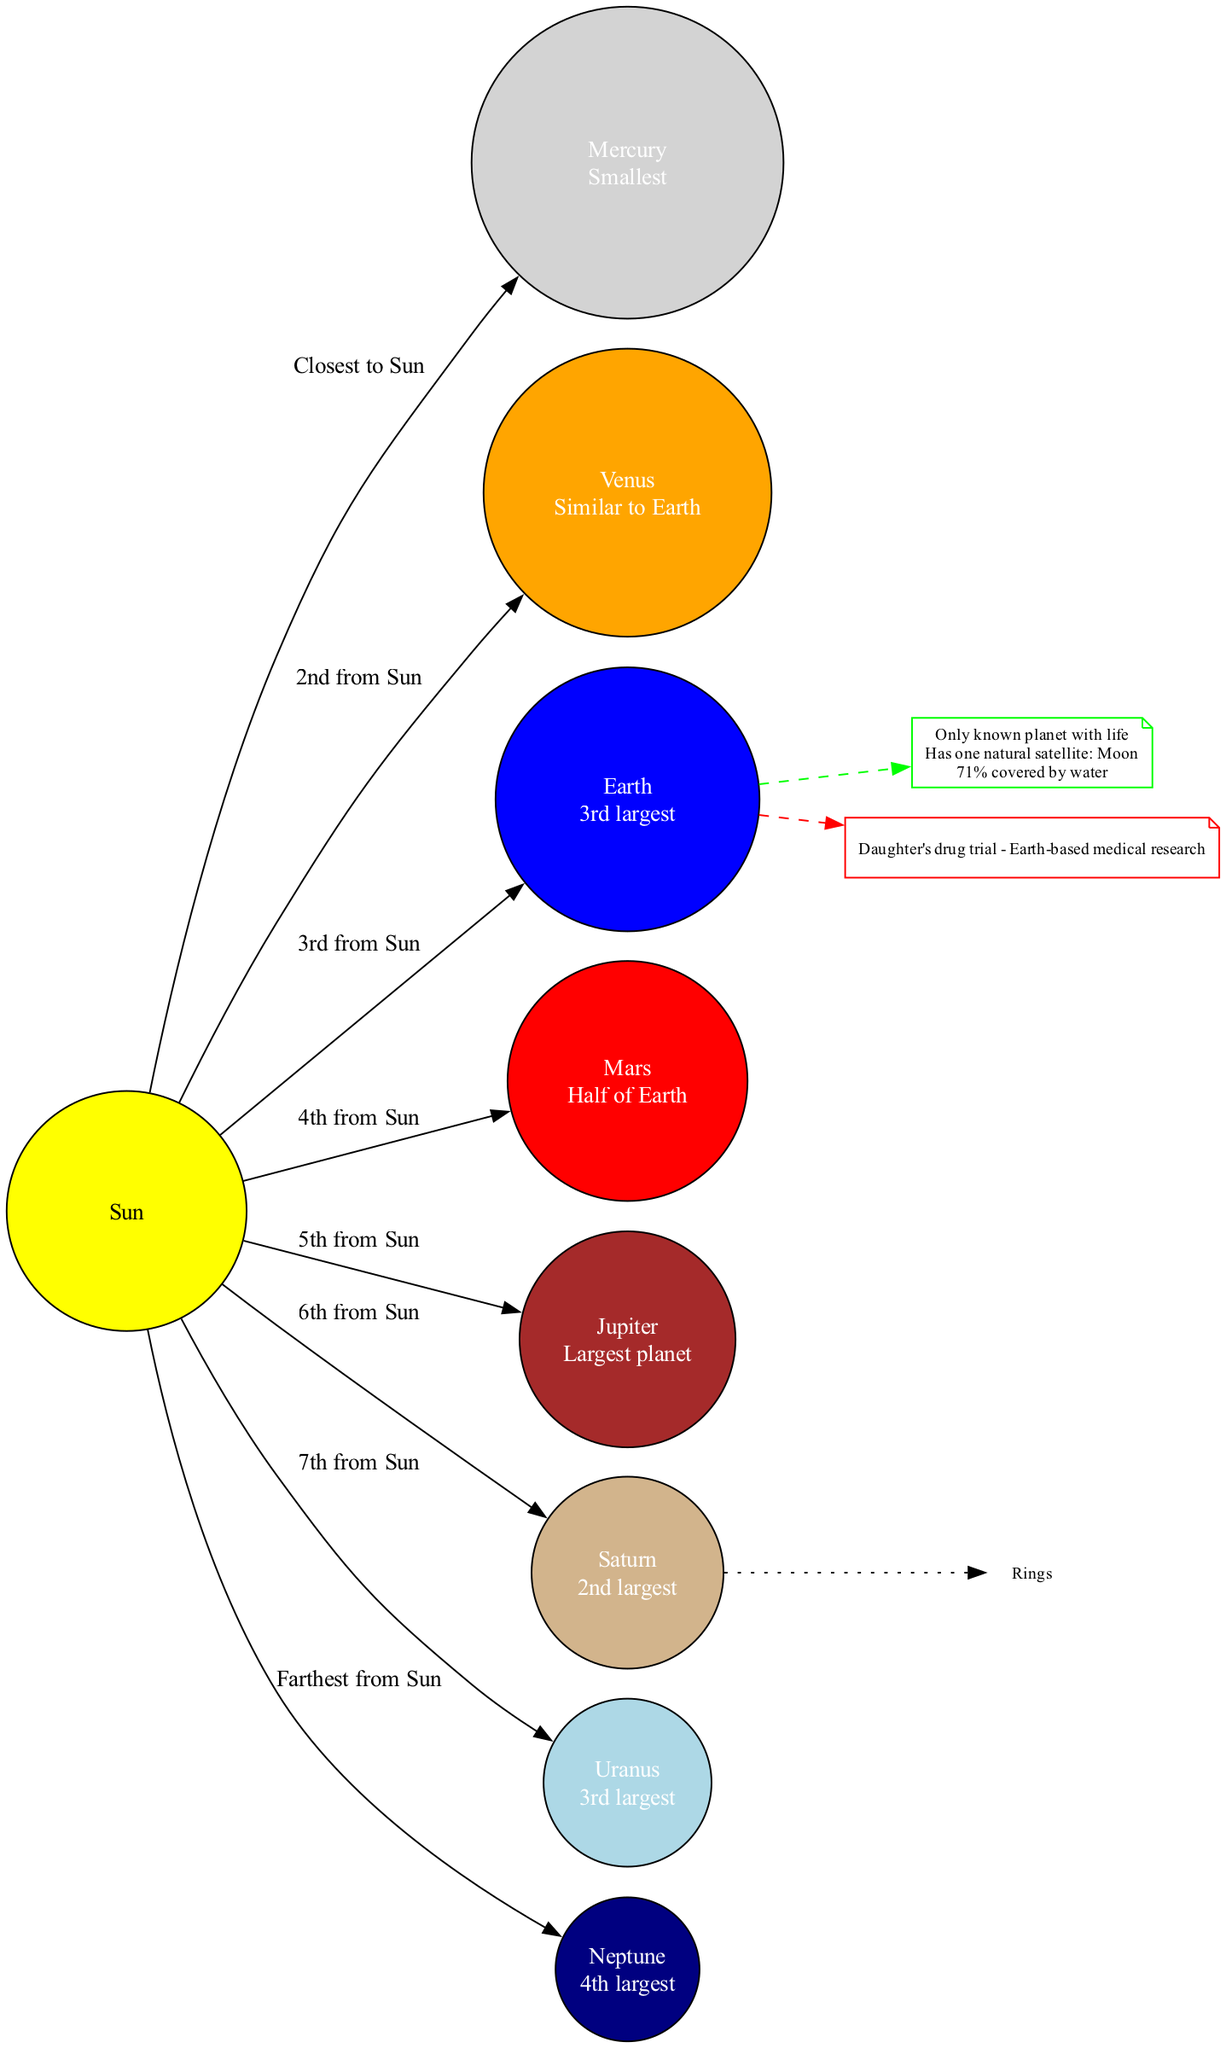What is the largest planet in the solar system? The diagram identifies Jupiter as the largest planet, which is indicated by the label next to the Jupiter node stating "Largest planet".
Answer: Jupiter How many planets are shown in the diagram? Counting the planetary nodes, there are a total of 8 planets represented in the diagram: Mercury, Venus, Earth, Mars, Jupiter, Saturn, Uranus, and Neptune.
Answer: 8 Which planet is Earth's closest neighbor? In the diagram, Mars is the 4th planet from the Sun, directly after Earth, which is the 3rd, making it Earth's closest neighbor.
Answer: Mars What notable feature is associated with Saturn? The diagram includes an annotation pointing to Saturn that mentions "Rings". This indicates that Saturn is well-known for its rings.
Answer: Rings What percentage of Earth is covered by water? The earth facts in the diagram explicitly state that 71% of Earth is covered by water.
Answer: 71% Which planet is known to have life? The diagram highlights Earth as "Only known planet with life", making it the only planet recognized for sustaining life.
Answer: Earth How many planets are situated between the Sun and Earth in the diagram? The planets listed before Earth in their orbital arrangement are Mercury and Venus, totaling 2 planets between the Sun and Earth.
Answer: 2 What natural satellite does Earth have? The earth facts section of the diagram mentions that Earth has one natural satellite called the Moon.
Answer: Moon Which planet orbits 6th from the Sun? The diagram shows Saturn as being the 6th planet from the Sun, as indicated by its position in the orbital arrangement.
Answer: Saturn What is the smallest planet in the solar system? According to the diagram, Mercury is identified as the smallest planet, labeled as the "Smallest" next to its node.
Answer: Mercury 